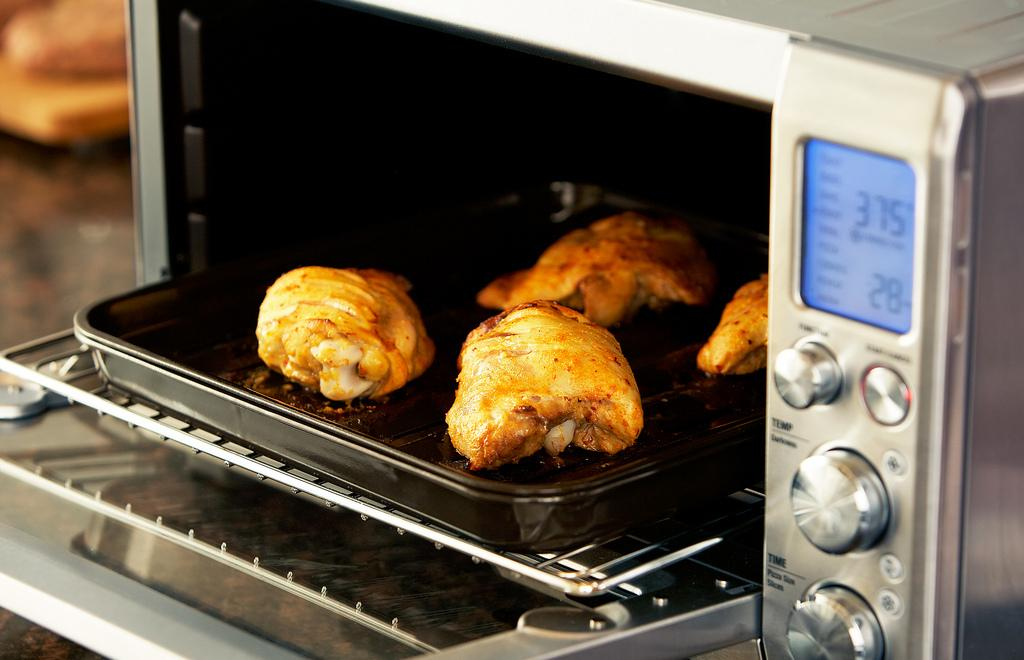<image>
Summarize the visual content of the image. chicken on a pan from a toaster over with temperature reading 375 